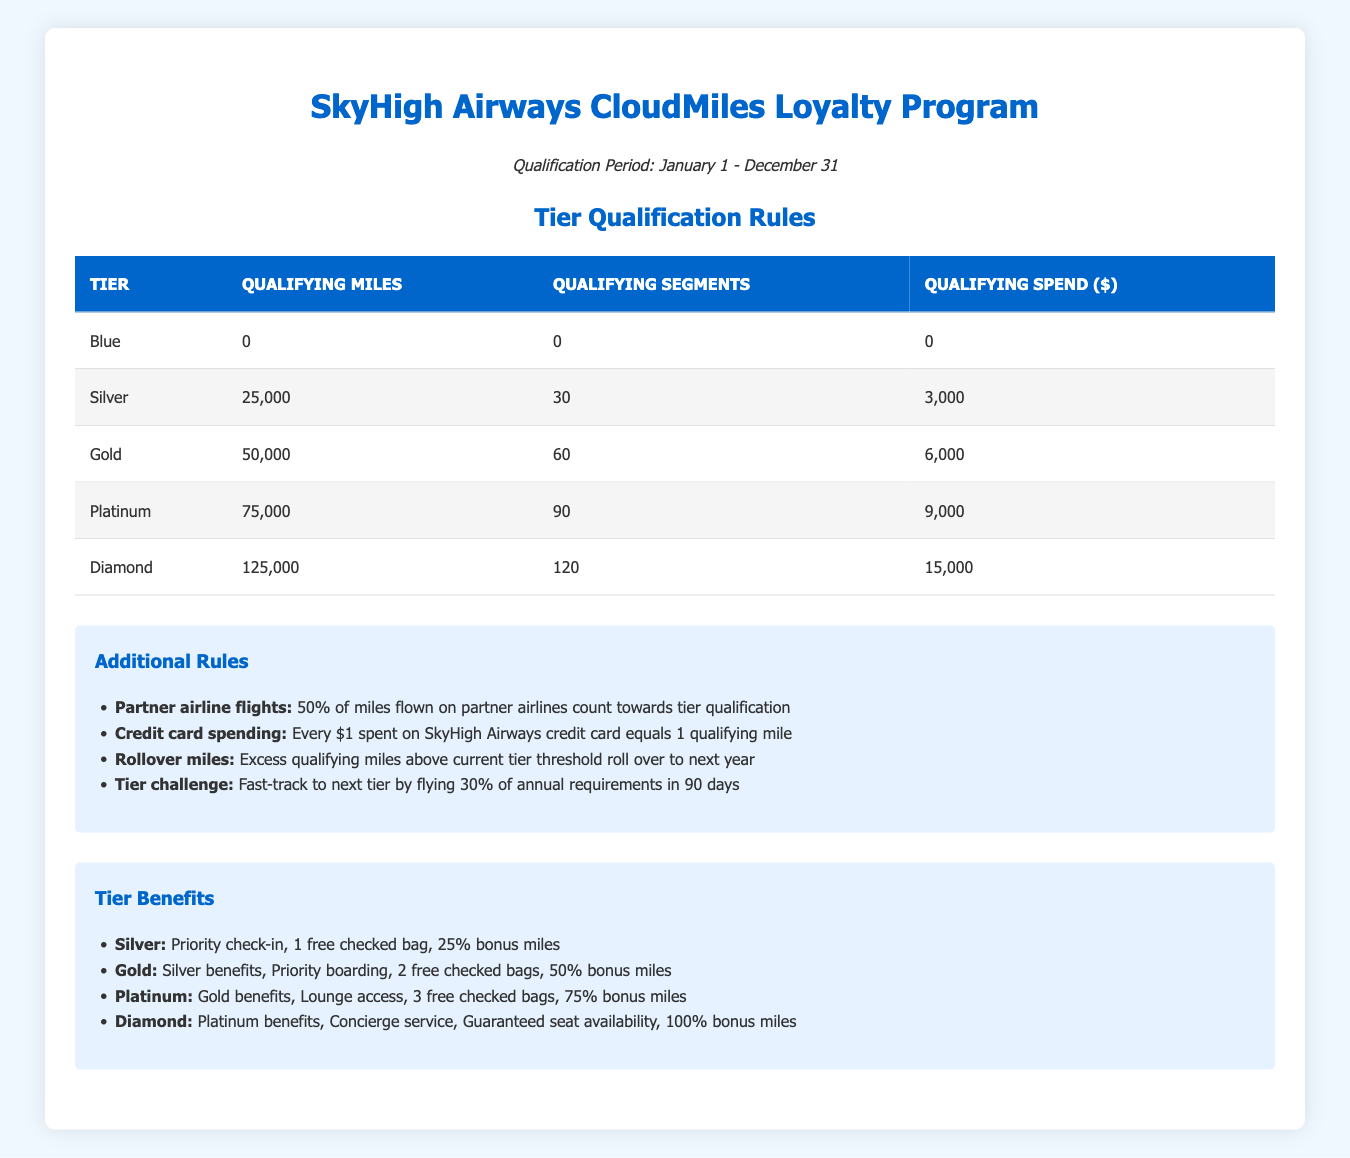What are the qualifying miles for the Gold tier? The Gold tier requires 50,000 qualifying miles, which is directly stated in the table under the "Qualifying Miles" column for the Gold row.
Answer: 50,000 How many segments are needed to qualify for the Platinum tier? The table shows that the Platinum tier requires 90 qualifying segments, which can be found in the corresponding row for Platinum under the "Qualifying Segments" column.
Answer: 90 Is it true that the Silver tier requires at least 25,000 qualifying miles? The table indicates that the Silver tier has qualifying miles set at 25,000. Since this value is greater than or equal to 25,000, the statement is true.
Answer: Yes If a customer has 80,000 qualifying miles, which tier do they qualify for? According to the table, a customer with 80,000 qualifying miles exceeds the qualifications for the Gold (50,000 miles) and Platinum (75,000 miles) tiers, but does not reach the Diamond tier (125,000 miles). Thus, they would qualify for the Platinum tier.
Answer: Platinum What is the total qualifying spend required to reach the Gold and Diamond tiers combined? The qualifying spend for the Gold tier is 6,000, and for the Diamond tier, it is 15,000. The total qualifying spend is calculated by adding these two amounts: 6,000 + 15,000 = 21,000.
Answer: 21,000 If a customer spent $4,000 on the SkyHigh Airways credit card, how many qualifying miles would that give them? Based on the rules, every dollar spent on the credit card counts as one qualifying mile. Therefore, $4,000 spent equals 4,000 qualifying miles.
Answer: 4,000 Can you fast-track to the next tier by completing a tier challenge? The text in the additional rules indicates that there is indeed a Tier Challenge rule that allows customers to fast-track to the next tier by flying 30% of annual requirements in 90 days. Therefore, the answer is yes.
Answer: Yes What is the minimum spend required for the Silver tier and how does it compare to the Gold tier? The minimum spend required for the Silver tier is 3,000, while for the Gold tier, it is 6,000. Therefore, the Gold tier requires an additional 3,000 compared to the Silver tier.
Answer: 3,000 more If a customer flew 50,000 miles but only had 55 segments, which tier do they qualify for? A customer with 50,000 miles satisfies the qualifying miles requirement for Silver, Gold, and Platinum tiers, but not the segment requirement for Platinum (90 segments). Therefore, they qualify for the Gold tier since they meet its requirements.
Answer: Gold 